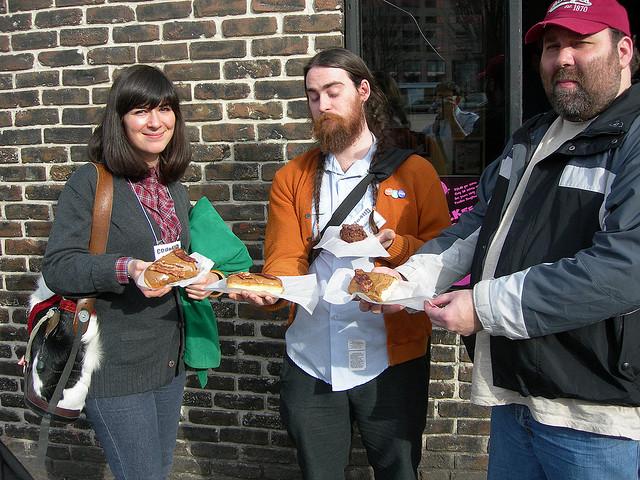Which man has a red hat?
Short answer required. Right. How many people have beards?
Give a very brief answer. 2. What are they holding in their hands?
Concise answer only. Food. 